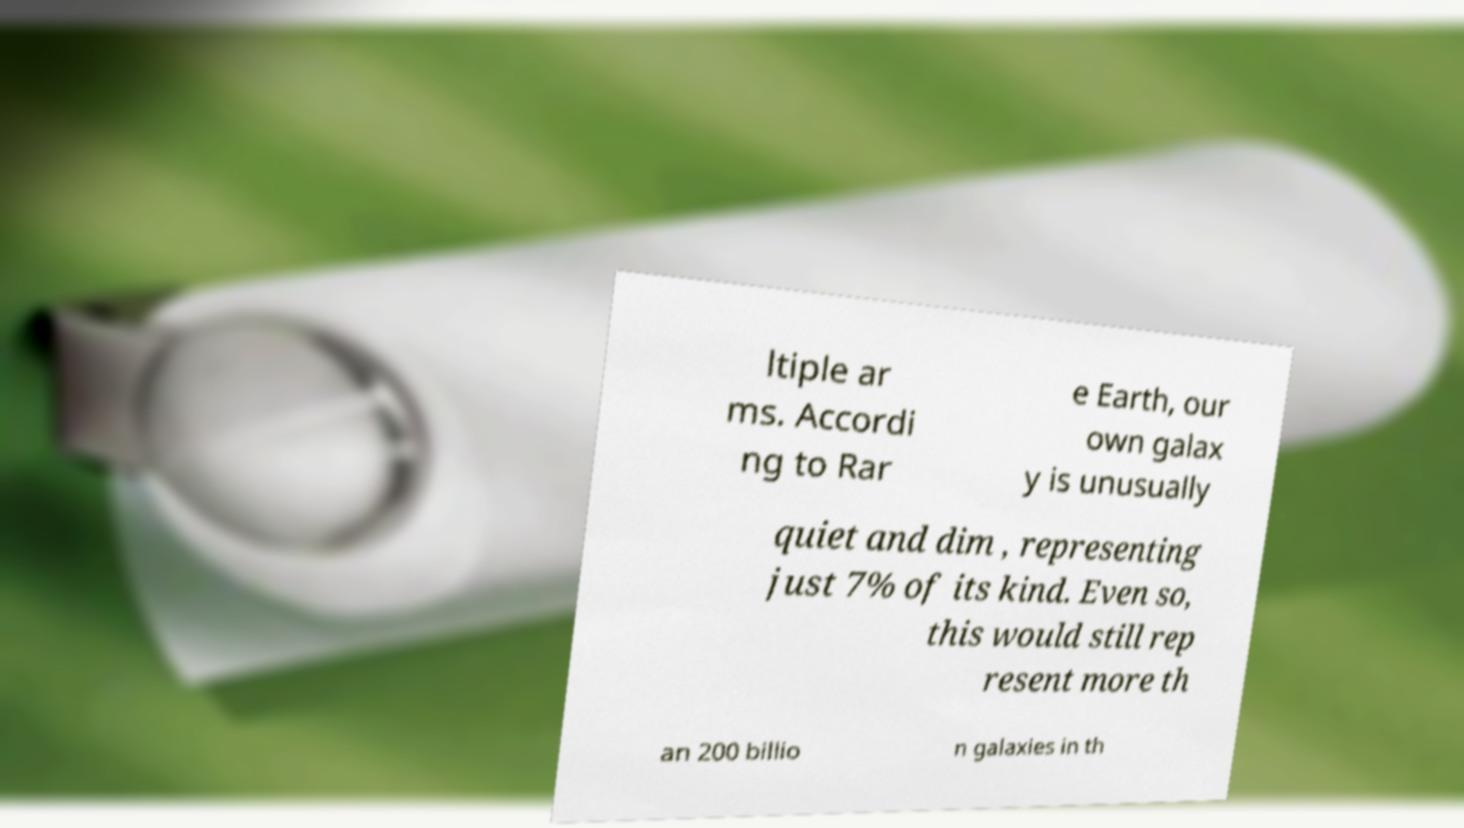What messages or text are displayed in this image? I need them in a readable, typed format. ltiple ar ms. Accordi ng to Rar e Earth, our own galax y is unusually quiet and dim , representing just 7% of its kind. Even so, this would still rep resent more th an 200 billio n galaxies in th 